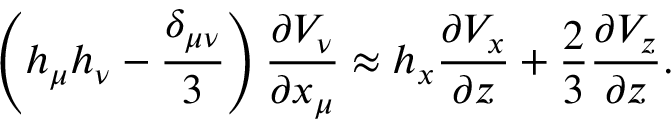<formula> <loc_0><loc_0><loc_500><loc_500>\left ( h _ { \mu } h _ { \nu } - \frac { \delta _ { \mu \nu } } { 3 } \right ) \frac { \partial V _ { \nu } } { \partial x _ { \mu } } \approx h _ { x } \frac { \partial V _ { x } } { \partial z } + \frac { 2 } { 3 } \frac { \partial V _ { z } } { \partial z } .</formula> 